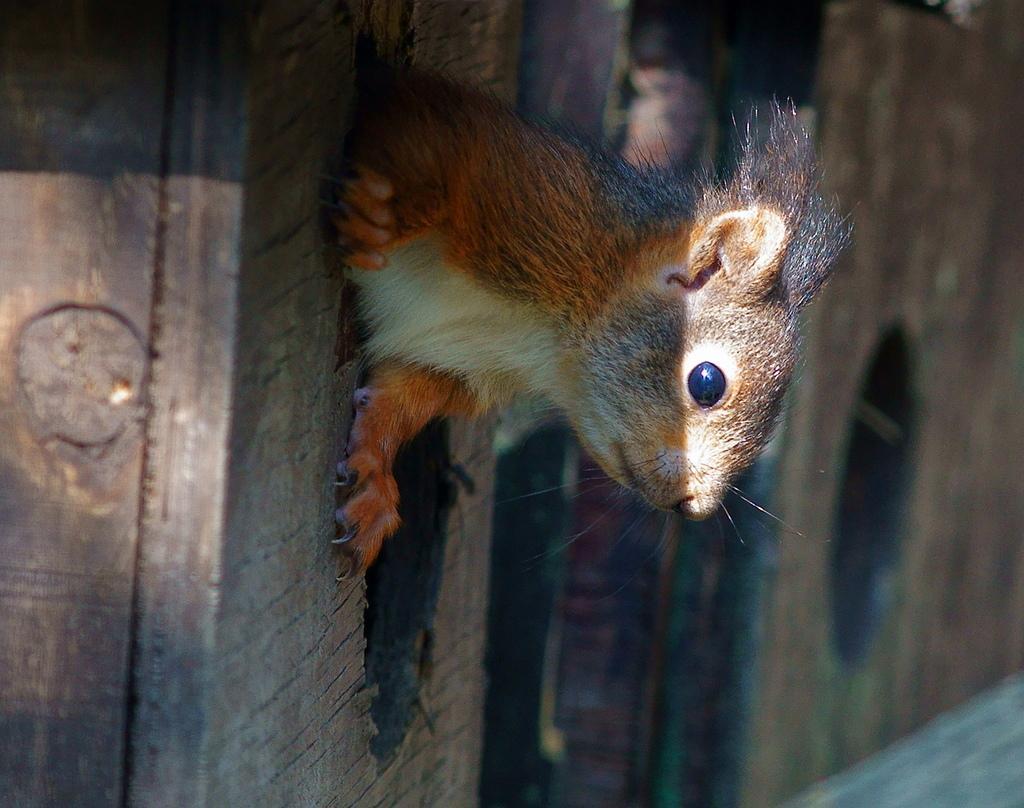In one or two sentences, can you explain what this image depicts? In this image in the center there is one animal and there is a wooden wall, at the bottom there is a walkway. 